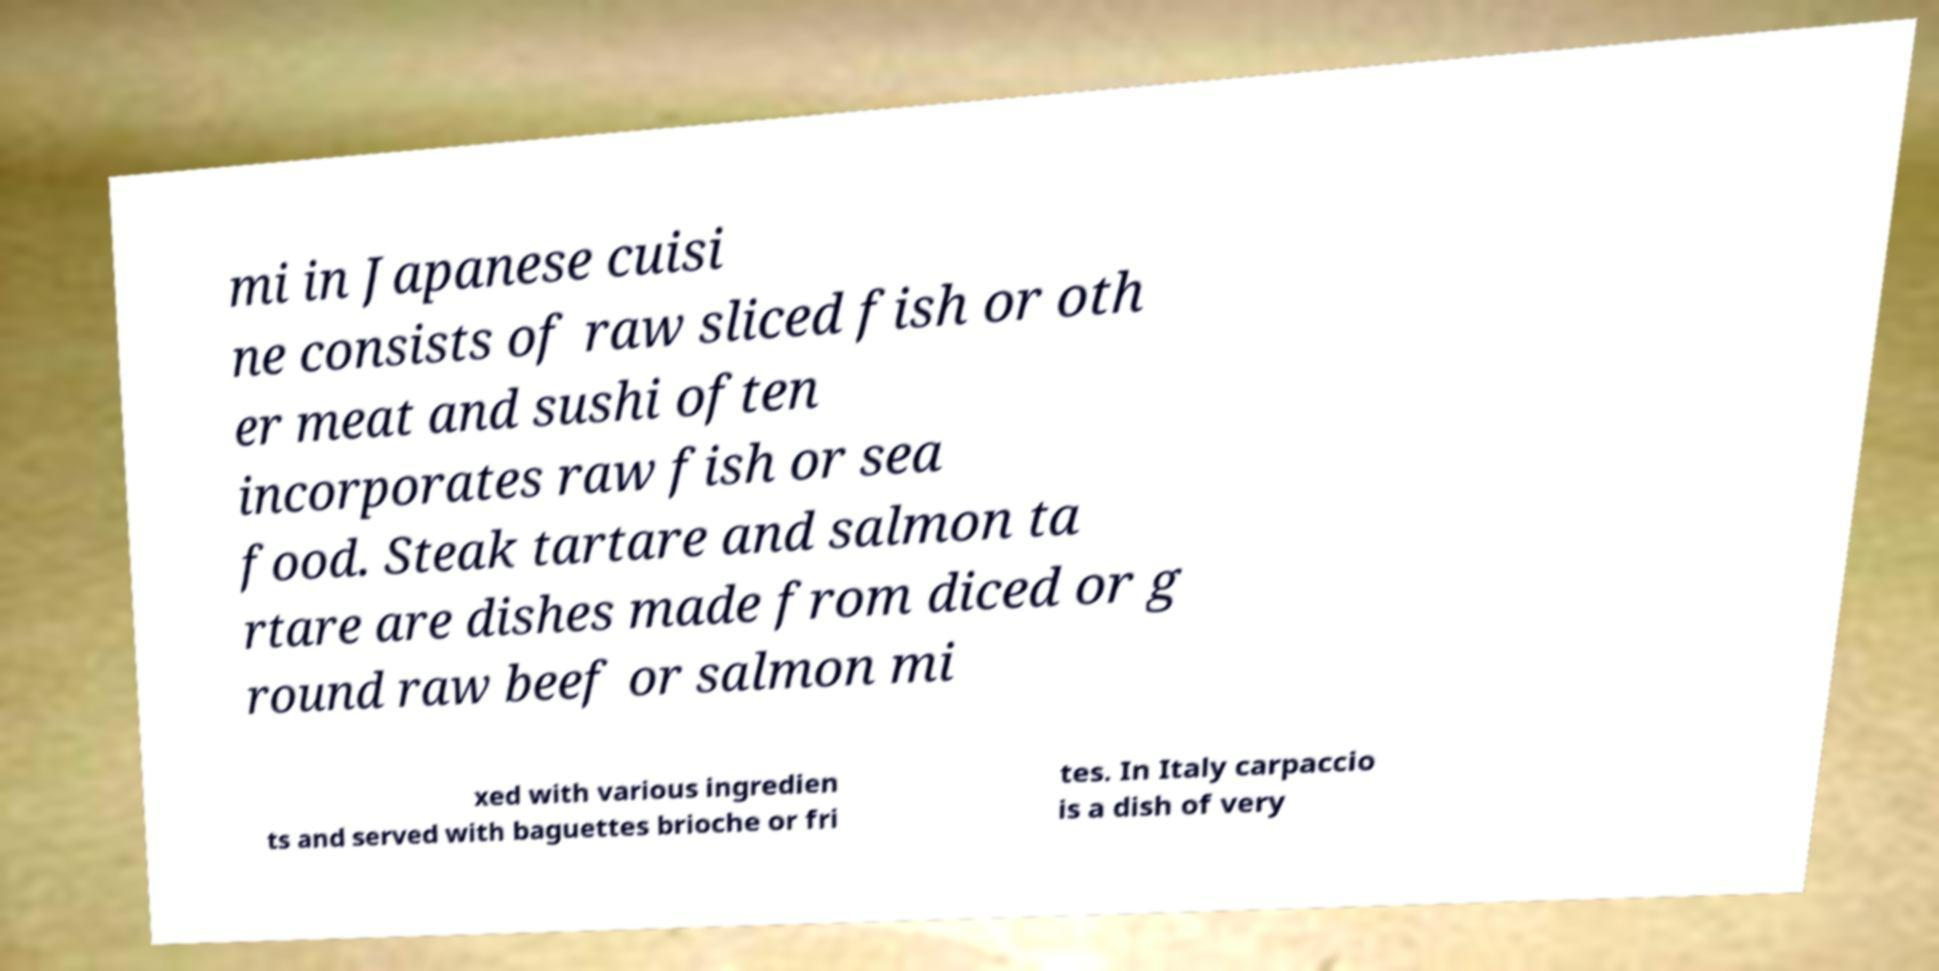For documentation purposes, I need the text within this image transcribed. Could you provide that? mi in Japanese cuisi ne consists of raw sliced fish or oth er meat and sushi often incorporates raw fish or sea food. Steak tartare and salmon ta rtare are dishes made from diced or g round raw beef or salmon mi xed with various ingredien ts and served with baguettes brioche or fri tes. In Italy carpaccio is a dish of very 